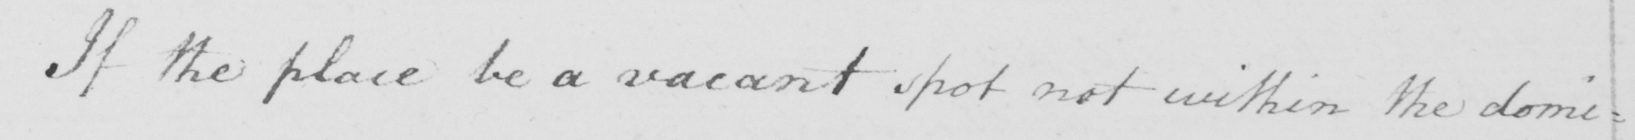What does this handwritten line say? If the place be a vacant spot not within the domi= 